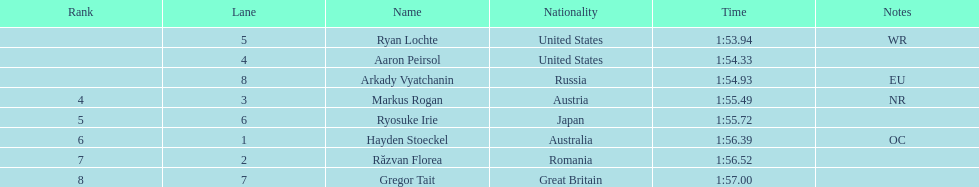In the contest, which country accumulated the most medals? United States. 